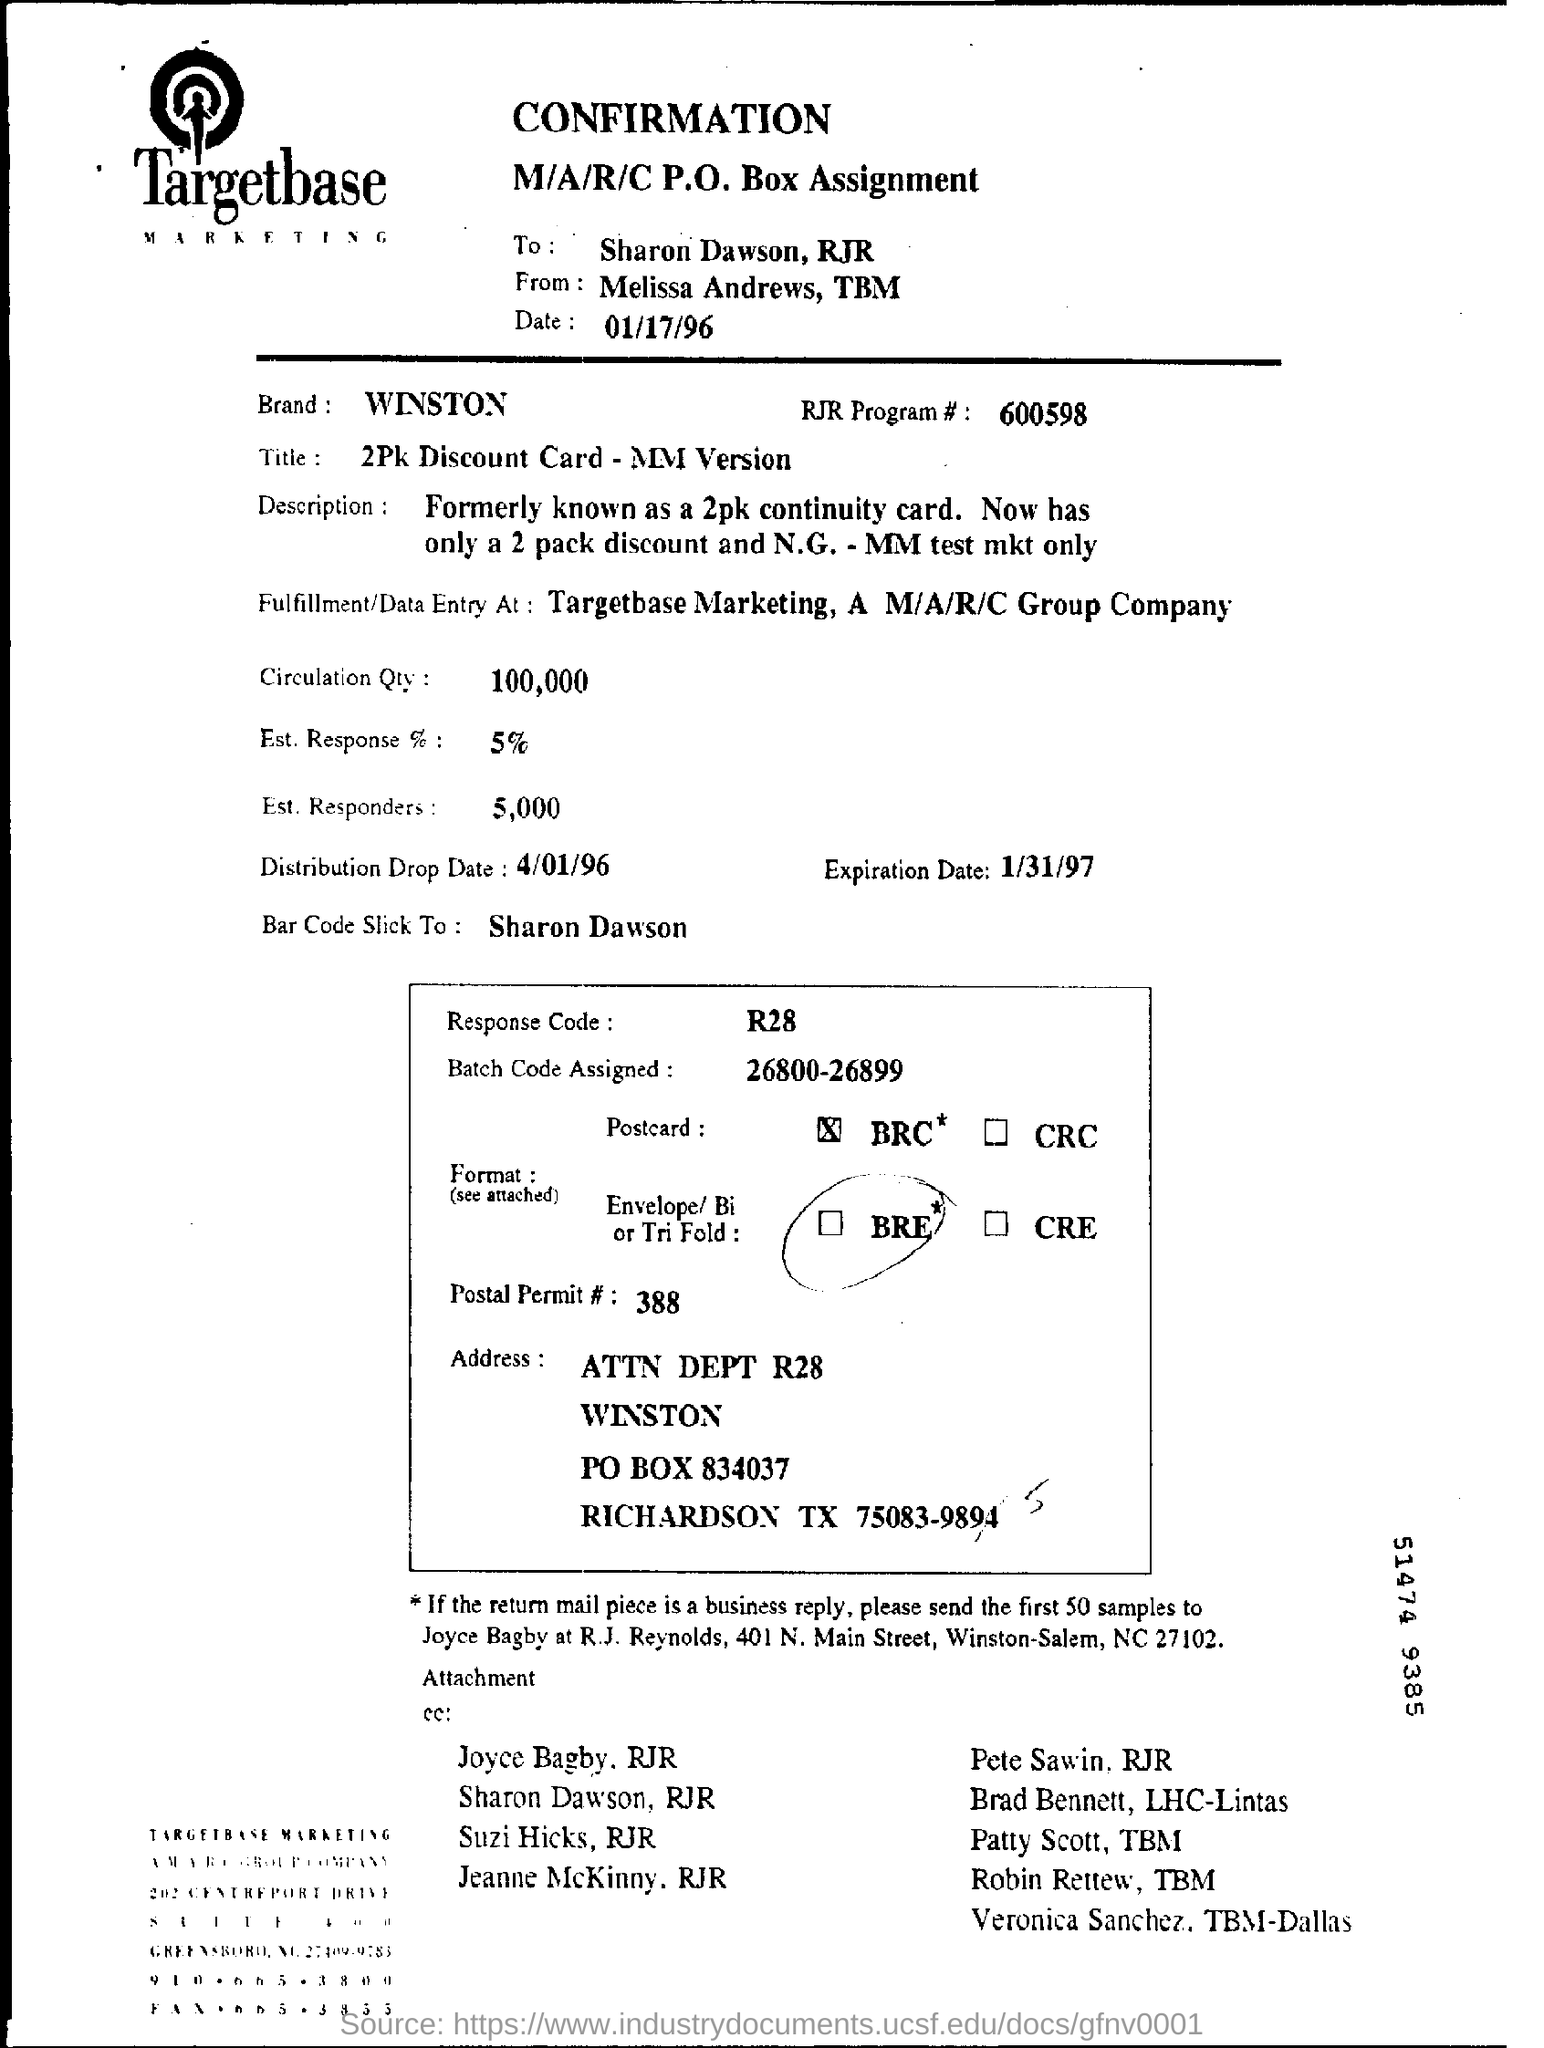Identify some key points in this picture. The distribution drop date is April 1, 1996. The response code is R28. What is the postal permit number? It is 388... The batch code assigned is between 26800 and 26899. The RJR Program # is 600598... 